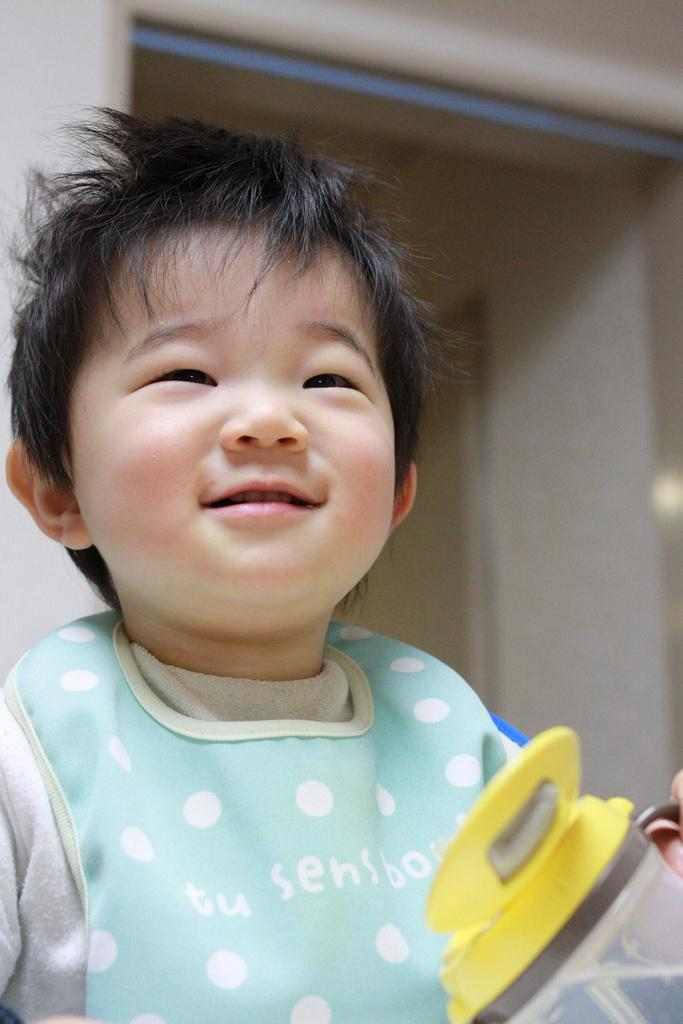Who is present in the image? There is a boy in the image. What object can be seen near the boy? There is a bottle in the image. What is visible behind the boy? There is a wall behind the boy. What type of wave can be seen crashing on the shore in the image? There is no wave or shore present in the image; it features a boy and a bottle with a wall in the background. 